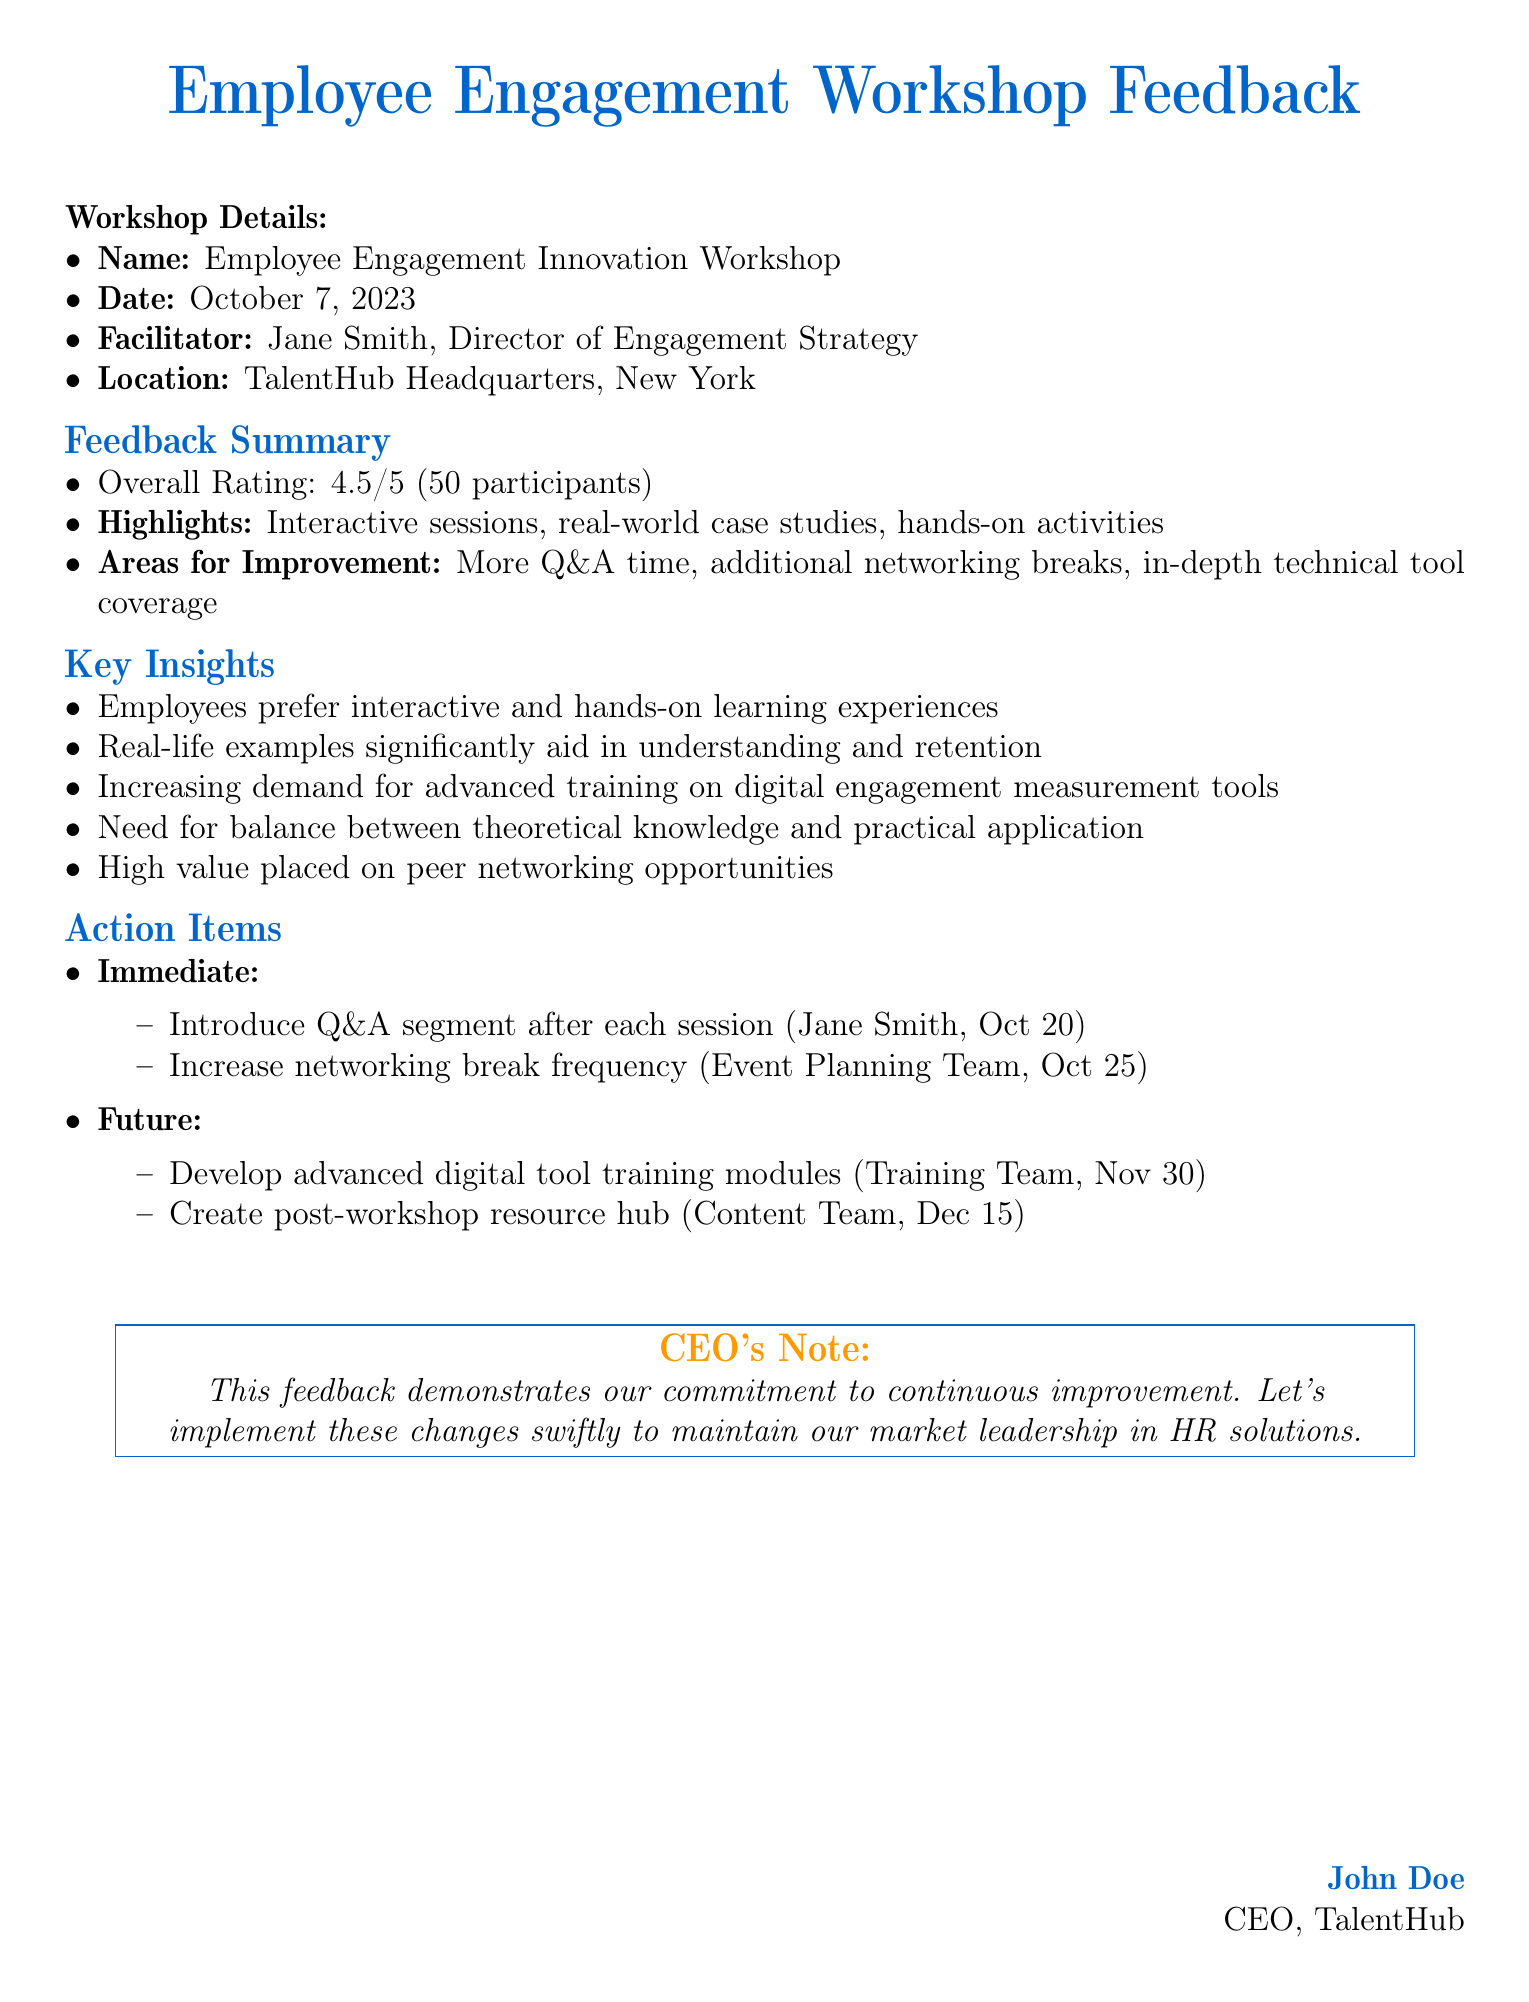What is the name of the workshop? The name of the workshop is specified in the document under Workshop Details.
Answer: Employee Engagement Innovation Workshop When did the workshop take place? The workshop date is clearly mentioned under Workshop Details.
Answer: October 7, 2023 Who facilitated the workshop? The facilitator's name is listed in the Workshop Details section.
Answer: Jane Smith What was the overall rating of the workshop? The overall rating is provided in the Feedback Summary section.
Answer: 4.5/5 What is one area for improvement noted in the feedback? The areas for improvement are summarized in the Feedback Summary section.
Answer: More Q&A time What is a key insight derived from the workshop feedback? Key insights are outlined in the Key Insights section of the document.
Answer: Employees prefer interactive and hands-on learning experiences What is one immediate action item identified? Immediate action items are listed in the Action Items section of the document.
Answer: Introduce Q&A segment after each session When is the advanced digital tool training modules deadline? The deadline for this future action item is stated in the Action Items section.
Answer: Nov 30 What is the role of Jane Smith? Jane Smith's title is provided in the Workshop Details section.
Answer: Director of Engagement Strategy What is the main purpose of the CEO's note? The purpose of the CEO's note is summarized at the end of the document.
Answer: Commitment to continuous improvement 